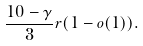Convert formula to latex. <formula><loc_0><loc_0><loc_500><loc_500>\frac { 1 0 - \gamma } { 3 } r ( 1 - o ( 1 ) ) .</formula> 